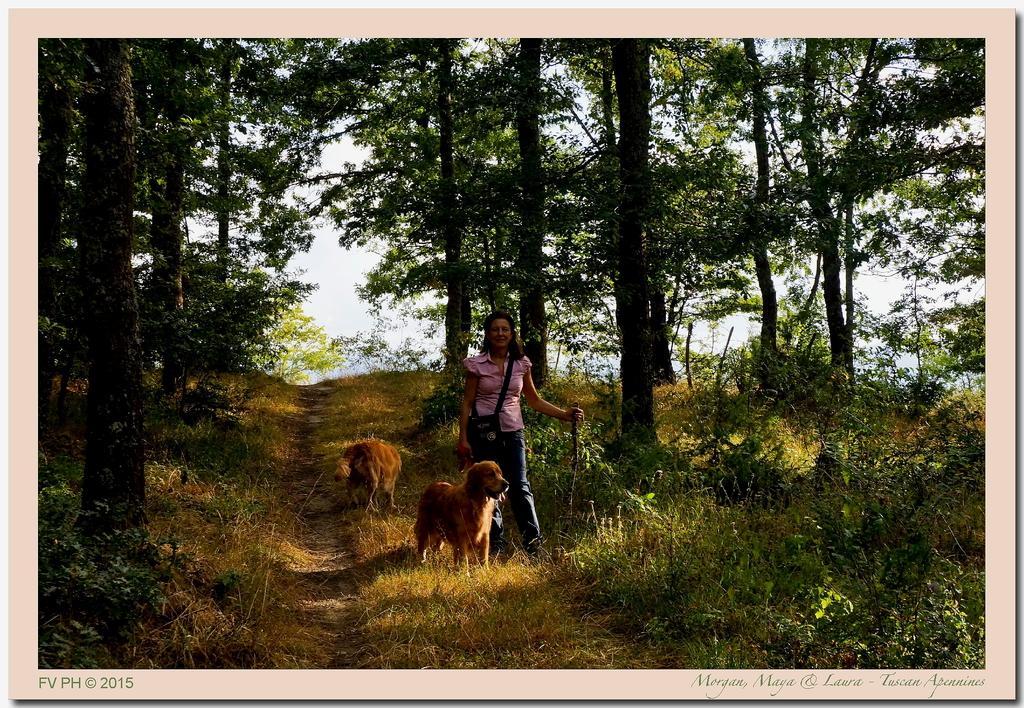Describe this image in one or two sentences. This is an edited image. In the middle of the image there is a woman holding a stick in the hand, standing and giving pose for the picture. Beside her there are two dogs. On the ground, I can see the grass. Here I can see many plants and trees. This place is looking like a forest. 